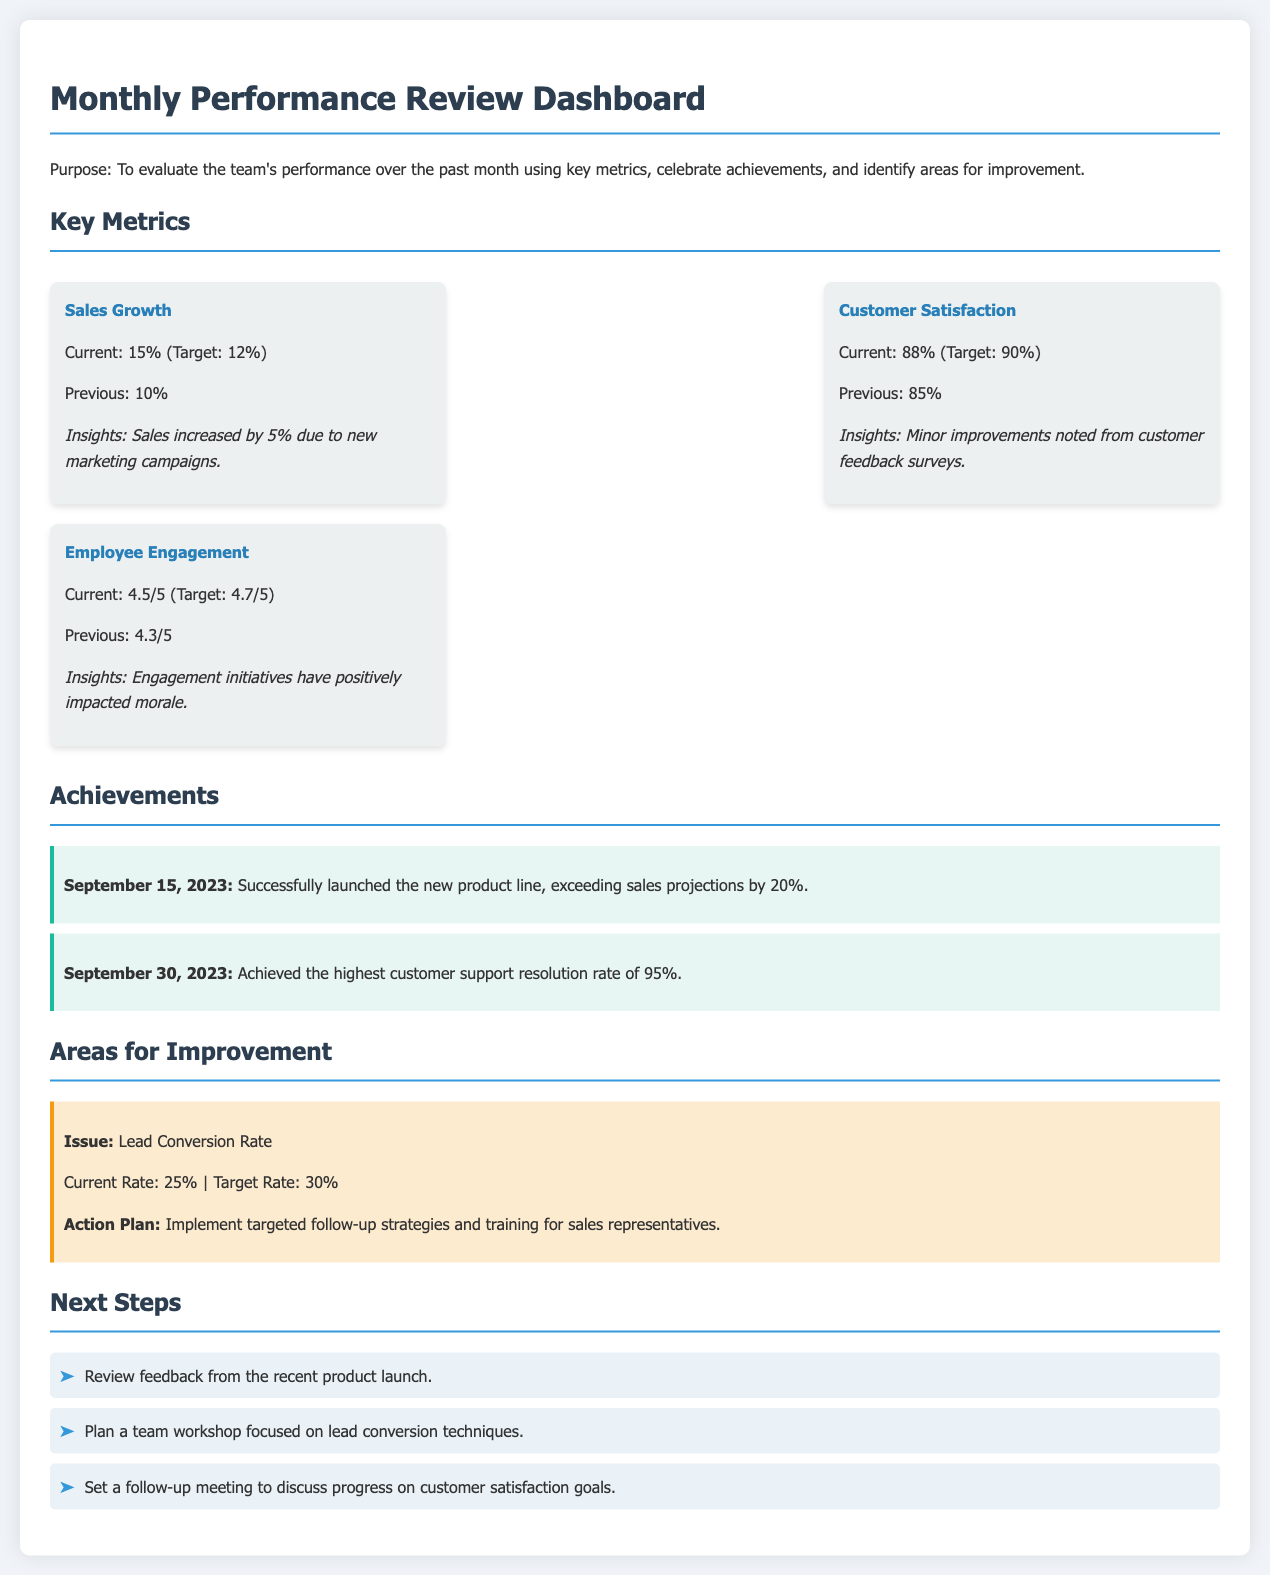What is the current sales growth percentage? The current sales growth percentage is stated in the Key Metrics section, which shows 15%.
Answer: 15% What was the highest customer support resolution rate achieved? The highest customer support resolution rate is mentioned in the Achievements section, which is 95%.
Answer: 95% What is the target customer satisfaction percentage? The target customer satisfaction percentage is listed in the Key Metrics section as 90%.
Answer: 90% What issue is highlighted for improvement? The issue highlighted for improvement is stated in the Areas for Improvement section, specifically the Lead Conversion Rate.
Answer: Lead Conversion Rate What was the achievement date of the product line launch? The date of the product line launch achievement is included in the Achievements section and is September 15, 2023.
Answer: September 15, 2023 What action plan is proposed for improving the Lead Conversion Rate? The document provides an action plan detailing the steps to address the issue, which involves implementing targeted follow-up strategies and training for sales representatives.
Answer: Implement targeted follow-up strategies and training for sales representatives What was the employee engagement rating in the previous month? The previous employee engagement rating is noted in the Key Metrics section, which states it was 4.3 out of 5.
Answer: 4.3/5 How many next steps are listed? The number of next steps is defined in the Next Steps section, which lists three action items.
Answer: Three 